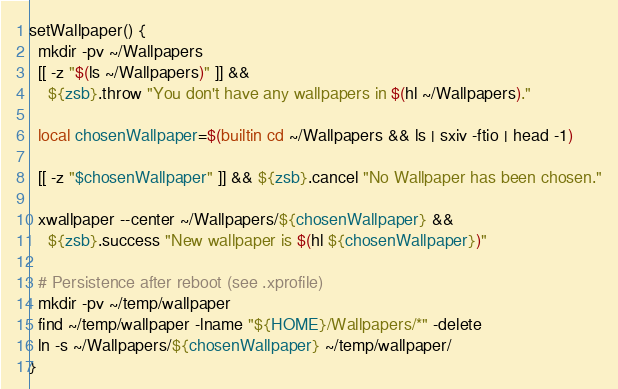Convert code to text. <code><loc_0><loc_0><loc_500><loc_500><_Bash_>setWallpaper() {
  mkdir -pv ~/Wallpapers
  [[ -z "$(ls ~/Wallpapers)" ]] &&
    ${zsb}.throw "You don't have any wallpapers in $(hl ~/Wallpapers)."

  local chosenWallpaper=$(builtin cd ~/Wallpapers && ls | sxiv -ftio | head -1)

  [[ -z "$chosenWallpaper" ]] && ${zsb}.cancel "No Wallpaper has been chosen."

  xwallpaper --center ~/Wallpapers/${chosenWallpaper} &&
    ${zsb}.success "New wallpaper is $(hl ${chosenWallpaper})"

  # Persistence after reboot (see .xprofile)
  mkdir -pv ~/temp/wallpaper
  find ~/temp/wallpaper -lname "${HOME}/Wallpapers/*" -delete
  ln -s ~/Wallpapers/${chosenWallpaper} ~/temp/wallpaper/
}
</code> 